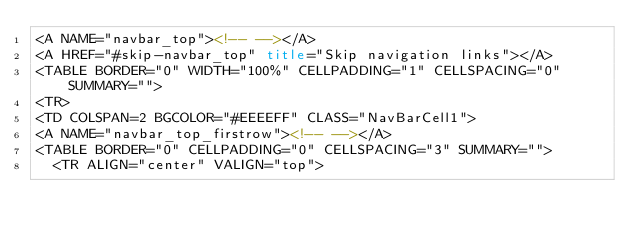<code> <loc_0><loc_0><loc_500><loc_500><_HTML_><A NAME="navbar_top"><!-- --></A>
<A HREF="#skip-navbar_top" title="Skip navigation links"></A>
<TABLE BORDER="0" WIDTH="100%" CELLPADDING="1" CELLSPACING="0" SUMMARY="">
<TR>
<TD COLSPAN=2 BGCOLOR="#EEEEFF" CLASS="NavBarCell1">
<A NAME="navbar_top_firstrow"><!-- --></A>
<TABLE BORDER="0" CELLPADDING="0" CELLSPACING="3" SUMMARY="">
  <TR ALIGN="center" VALIGN="top"></code> 